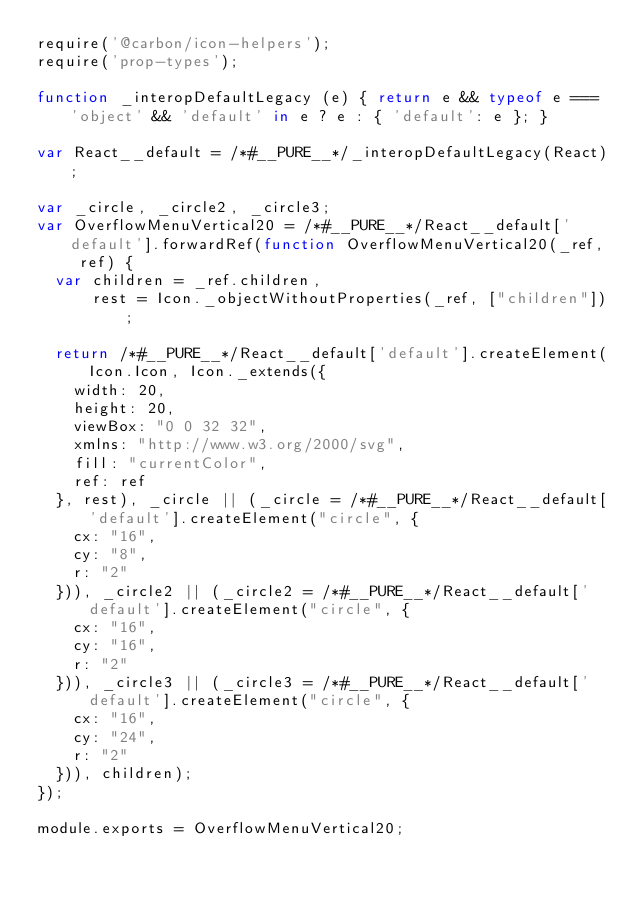Convert code to text. <code><loc_0><loc_0><loc_500><loc_500><_JavaScript_>require('@carbon/icon-helpers');
require('prop-types');

function _interopDefaultLegacy (e) { return e && typeof e === 'object' && 'default' in e ? e : { 'default': e }; }

var React__default = /*#__PURE__*/_interopDefaultLegacy(React);

var _circle, _circle2, _circle3;
var OverflowMenuVertical20 = /*#__PURE__*/React__default['default'].forwardRef(function OverflowMenuVertical20(_ref, ref) {
  var children = _ref.children,
      rest = Icon._objectWithoutProperties(_ref, ["children"]);

  return /*#__PURE__*/React__default['default'].createElement(Icon.Icon, Icon._extends({
    width: 20,
    height: 20,
    viewBox: "0 0 32 32",
    xmlns: "http://www.w3.org/2000/svg",
    fill: "currentColor",
    ref: ref
  }, rest), _circle || (_circle = /*#__PURE__*/React__default['default'].createElement("circle", {
    cx: "16",
    cy: "8",
    r: "2"
  })), _circle2 || (_circle2 = /*#__PURE__*/React__default['default'].createElement("circle", {
    cx: "16",
    cy: "16",
    r: "2"
  })), _circle3 || (_circle3 = /*#__PURE__*/React__default['default'].createElement("circle", {
    cx: "16",
    cy: "24",
    r: "2"
  })), children);
});

module.exports = OverflowMenuVertical20;
</code> 